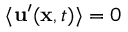<formula> <loc_0><loc_0><loc_500><loc_500>\langle u ^ { \prime } ( x , t ) \rangle = 0</formula> 